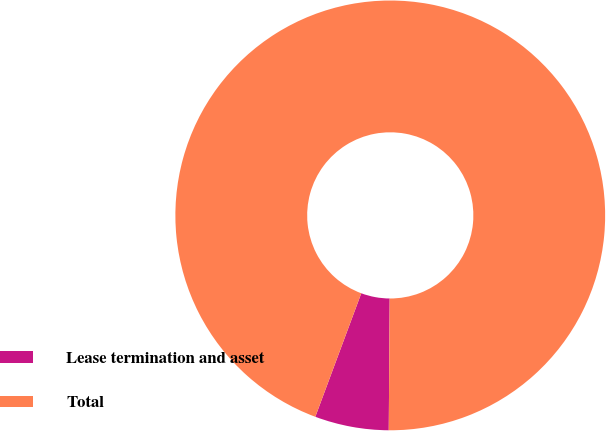Convert chart to OTSL. <chart><loc_0><loc_0><loc_500><loc_500><pie_chart><fcel>Lease termination and asset<fcel>Total<nl><fcel>5.56%<fcel>94.44%<nl></chart> 